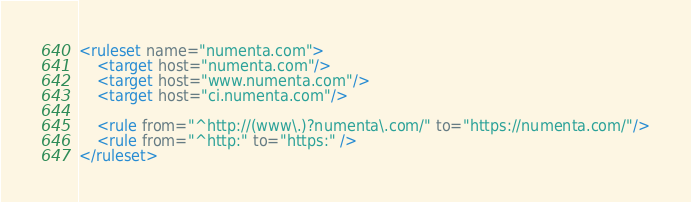<code> <loc_0><loc_0><loc_500><loc_500><_XML_><ruleset name="numenta.com">
    <target host="numenta.com"/>
    <target host="www.numenta.com"/>
    <target host="ci.numenta.com"/>
    
    <rule from="^http://(www\.)?numenta\.com/" to="https://numenta.com/"/>
    <rule from="^http:" to="https:" />
</ruleset>
</code> 